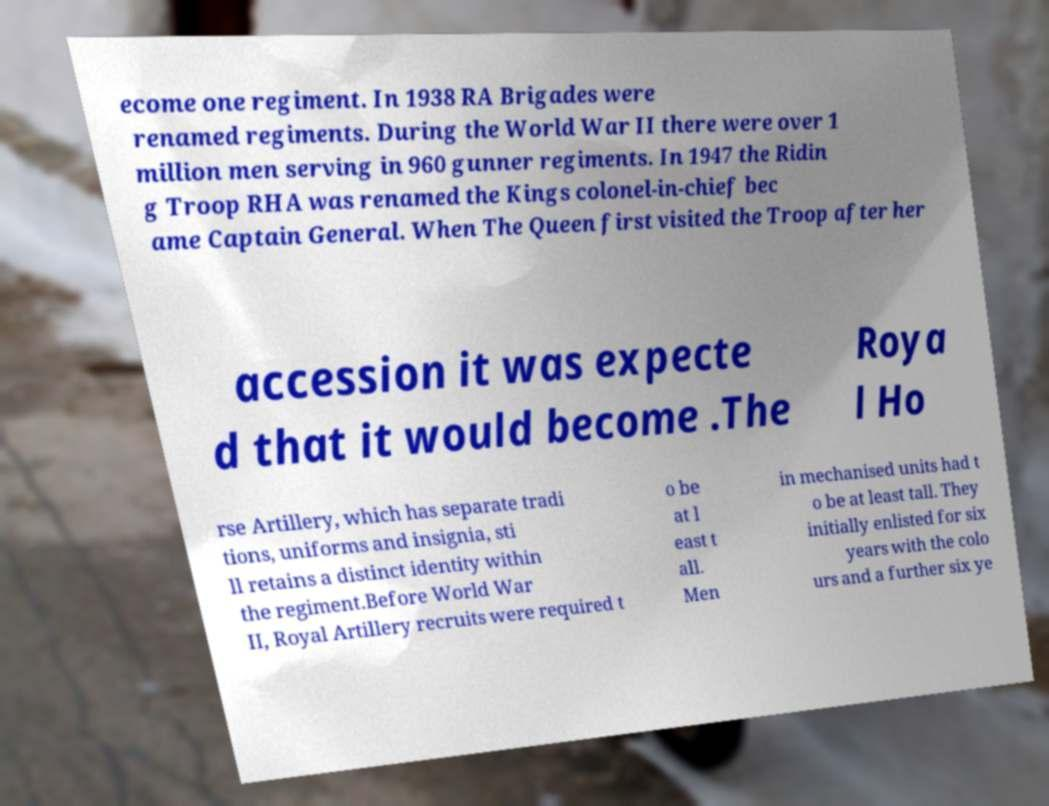I need the written content from this picture converted into text. Can you do that? ecome one regiment. In 1938 RA Brigades were renamed regiments. During the World War II there were over 1 million men serving in 960 gunner regiments. In 1947 the Ridin g Troop RHA was renamed the Kings colonel-in-chief bec ame Captain General. When The Queen first visited the Troop after her accession it was expecte d that it would become .The Roya l Ho rse Artillery, which has separate tradi tions, uniforms and insignia, sti ll retains a distinct identity within the regiment.Before World War II, Royal Artillery recruits were required t o be at l east t all. Men in mechanised units had t o be at least tall. They initially enlisted for six years with the colo urs and a further six ye 